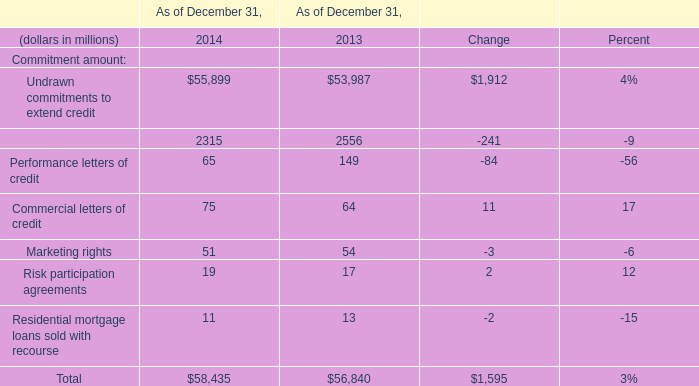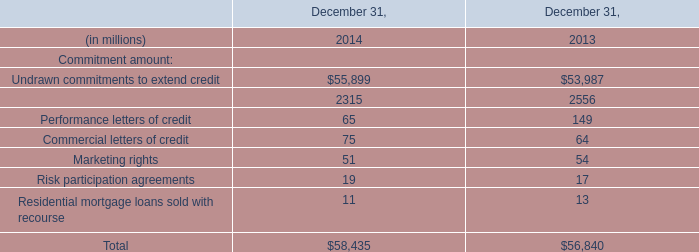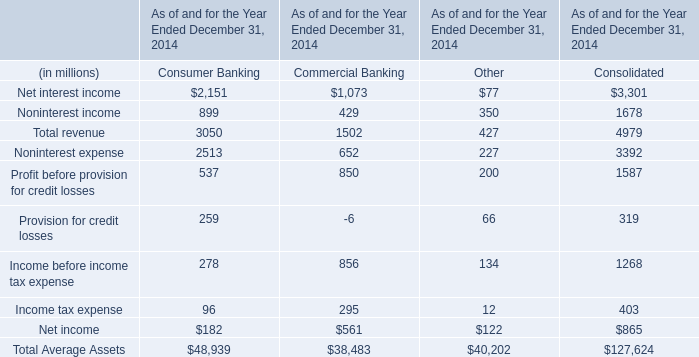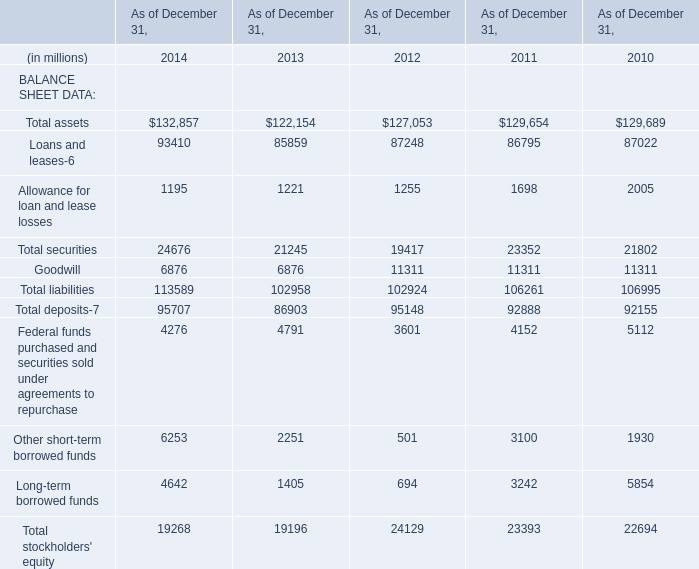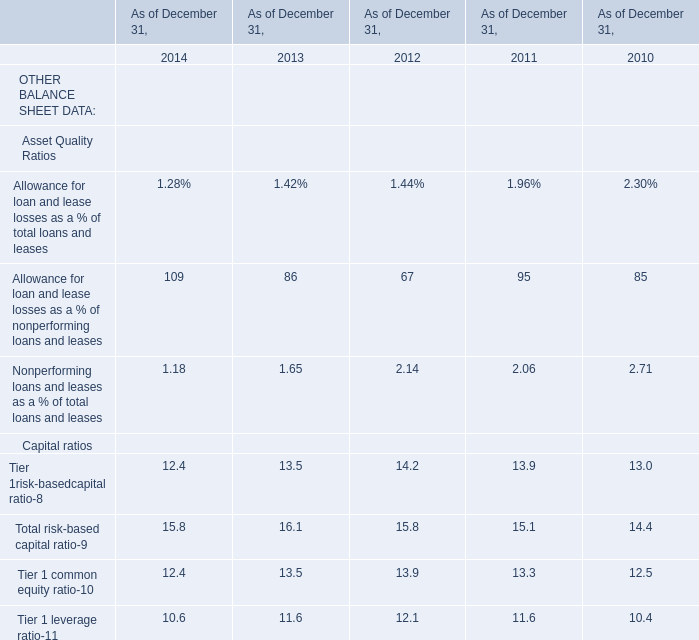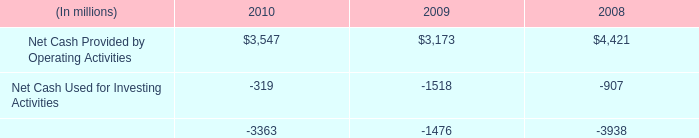What's the greatest value of Capital ratios in 2014? 
Answer: 15.8. 